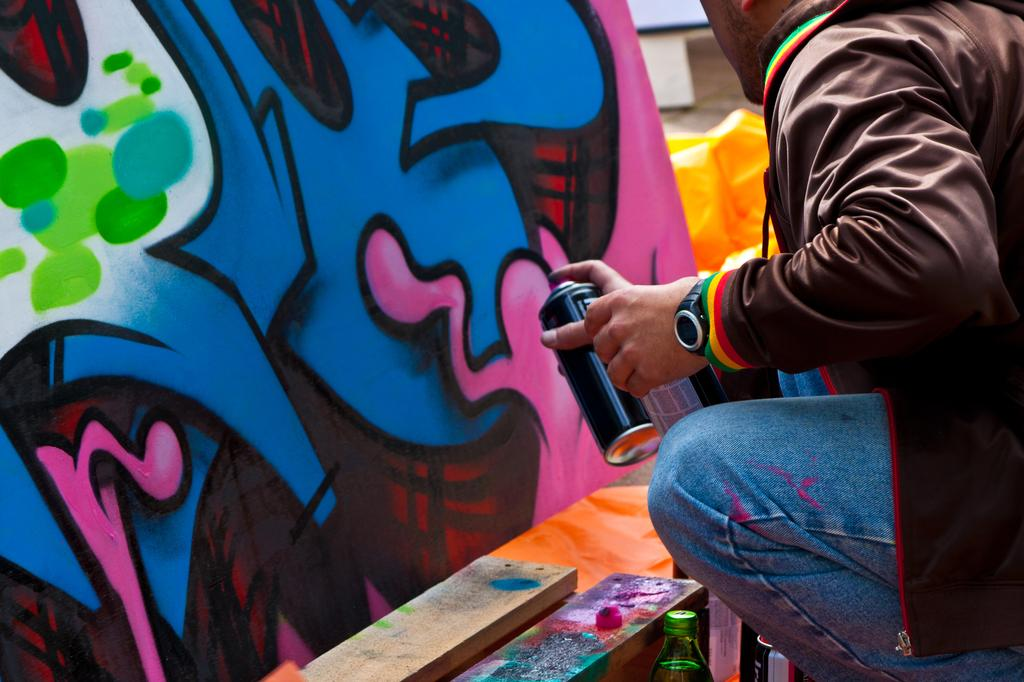Who is the person in the image? There is a man in the image. What is the man doing in the image? The man is sitting and painting a wall. What objects can be seen in the image besides the man? There are wooden sticks and bottles in the image. What type of park is visible in the background of the image? There is no park visible in the background of the image. 